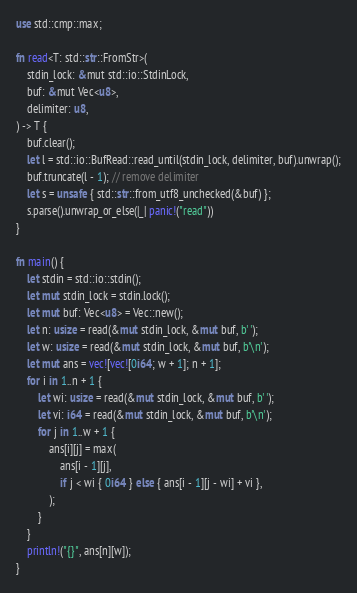<code> <loc_0><loc_0><loc_500><loc_500><_Rust_>use std::cmp::max;

fn read<T: std::str::FromStr>(
    stdin_lock: &mut std::io::StdinLock,
    buf: &mut Vec<u8>,
    delimiter: u8,
) -> T {
    buf.clear();
    let l = std::io::BufRead::read_until(stdin_lock, delimiter, buf).unwrap();
    buf.truncate(l - 1); // remove delimiter
    let s = unsafe { std::str::from_utf8_unchecked(&buf) };
    s.parse().unwrap_or_else(|_| panic!("read"))
}

fn main() {
    let stdin = std::io::stdin();
    let mut stdin_lock = stdin.lock();
    let mut buf: Vec<u8> = Vec::new();
    let n: usize = read(&mut stdin_lock, &mut buf, b' ');
    let w: usize = read(&mut stdin_lock, &mut buf, b'\n');
    let mut ans = vec![vec![0i64; w + 1]; n + 1];
    for i in 1..n + 1 {
        let wi: usize = read(&mut stdin_lock, &mut buf, b' ');
        let vi: i64 = read(&mut stdin_lock, &mut buf, b'\n');
        for j in 1..w + 1 {
            ans[i][j] = max(
                ans[i - 1][j],
                if j < wi { 0i64 } else { ans[i - 1][j - wi] + vi },
            );
        }
    }
    println!("{}", ans[n][w]);
}
</code> 